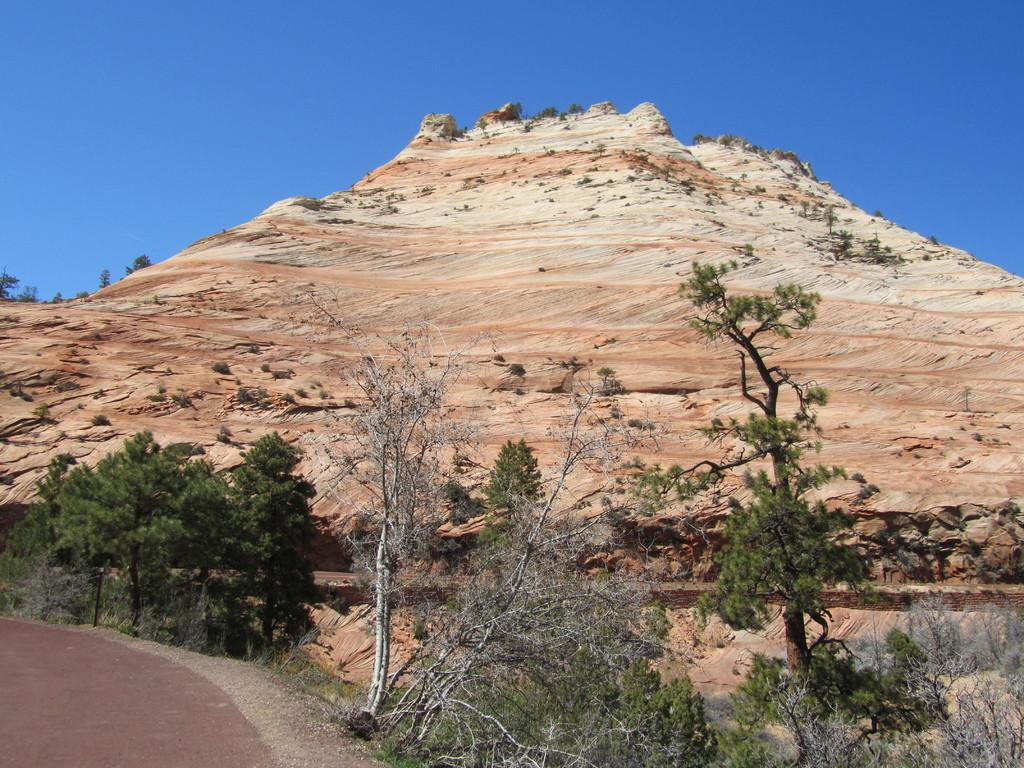Where was the picture taken? The picture was clicked outside. What can be seen in the foreground of the image? There are plants and the ground visible in the foreground of the image. What is visible in the background of the image? The sky and a hill are visible in the background of the image. Can you describe any other elements in the background of the image? There are other unspecified items in the background of the image. What type of secretary can be seen in the image? There is no secretary present in the image; it is an outdoor scene with plants, ground, sky, a hill, and other unspecified items. 